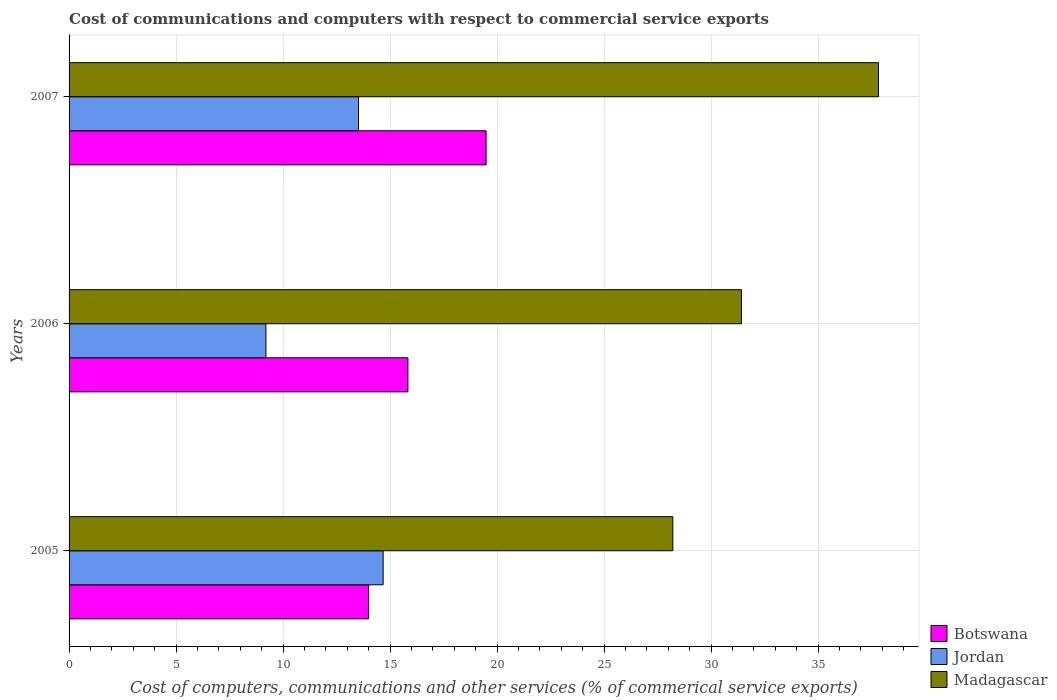How many groups of bars are there?
Give a very brief answer. 3. Are the number of bars on each tick of the Y-axis equal?
Offer a very short reply. Yes. In how many cases, is the number of bars for a given year not equal to the number of legend labels?
Ensure brevity in your answer.  0. What is the cost of communications and computers in Botswana in 2005?
Give a very brief answer. 14. Across all years, what is the maximum cost of communications and computers in Botswana?
Your response must be concise. 19.49. Across all years, what is the minimum cost of communications and computers in Botswana?
Offer a very short reply. 14. What is the total cost of communications and computers in Madagascar in the graph?
Your answer should be very brief. 97.46. What is the difference between the cost of communications and computers in Botswana in 2005 and that in 2007?
Provide a succinct answer. -5.49. What is the difference between the cost of communications and computers in Madagascar in 2005 and the cost of communications and computers in Botswana in 2007?
Make the answer very short. 8.73. What is the average cost of communications and computers in Botswana per year?
Offer a terse response. 16.44. In the year 2006, what is the difference between the cost of communications and computers in Madagascar and cost of communications and computers in Botswana?
Your answer should be compact. 15.59. What is the ratio of the cost of communications and computers in Botswana in 2005 to that in 2006?
Offer a very short reply. 0.88. Is the cost of communications and computers in Jordan in 2006 less than that in 2007?
Make the answer very short. Yes. Is the difference between the cost of communications and computers in Madagascar in 2006 and 2007 greater than the difference between the cost of communications and computers in Botswana in 2006 and 2007?
Provide a short and direct response. No. What is the difference between the highest and the second highest cost of communications and computers in Madagascar?
Your answer should be compact. 6.41. What is the difference between the highest and the lowest cost of communications and computers in Botswana?
Provide a succinct answer. 5.49. In how many years, is the cost of communications and computers in Madagascar greater than the average cost of communications and computers in Madagascar taken over all years?
Offer a very short reply. 1. Is the sum of the cost of communications and computers in Jordan in 2005 and 2006 greater than the maximum cost of communications and computers in Madagascar across all years?
Your answer should be very brief. No. What does the 3rd bar from the top in 2006 represents?
Your response must be concise. Botswana. What does the 3rd bar from the bottom in 2006 represents?
Ensure brevity in your answer.  Madagascar. How many bars are there?
Give a very brief answer. 9. Does the graph contain any zero values?
Your answer should be compact. No. Does the graph contain grids?
Your response must be concise. Yes. What is the title of the graph?
Your answer should be compact. Cost of communications and computers with respect to commercial service exports. What is the label or title of the X-axis?
Your answer should be very brief. Cost of computers, communications and other services (% of commerical service exports). What is the Cost of computers, communications and other services (% of commerical service exports) in Botswana in 2005?
Your response must be concise. 14. What is the Cost of computers, communications and other services (% of commerical service exports) of Jordan in 2005?
Make the answer very short. 14.68. What is the Cost of computers, communications and other services (% of commerical service exports) of Madagascar in 2005?
Keep it short and to the point. 28.21. What is the Cost of computers, communications and other services (% of commerical service exports) of Botswana in 2006?
Give a very brief answer. 15.83. What is the Cost of computers, communications and other services (% of commerical service exports) in Jordan in 2006?
Your answer should be compact. 9.2. What is the Cost of computers, communications and other services (% of commerical service exports) in Madagascar in 2006?
Provide a short and direct response. 31.42. What is the Cost of computers, communications and other services (% of commerical service exports) of Botswana in 2007?
Provide a succinct answer. 19.49. What is the Cost of computers, communications and other services (% of commerical service exports) of Jordan in 2007?
Offer a terse response. 13.53. What is the Cost of computers, communications and other services (% of commerical service exports) of Madagascar in 2007?
Provide a short and direct response. 37.83. Across all years, what is the maximum Cost of computers, communications and other services (% of commerical service exports) of Botswana?
Keep it short and to the point. 19.49. Across all years, what is the maximum Cost of computers, communications and other services (% of commerical service exports) in Jordan?
Offer a very short reply. 14.68. Across all years, what is the maximum Cost of computers, communications and other services (% of commerical service exports) of Madagascar?
Your answer should be compact. 37.83. Across all years, what is the minimum Cost of computers, communications and other services (% of commerical service exports) of Botswana?
Provide a succinct answer. 14. Across all years, what is the minimum Cost of computers, communications and other services (% of commerical service exports) in Jordan?
Your answer should be compact. 9.2. Across all years, what is the minimum Cost of computers, communications and other services (% of commerical service exports) of Madagascar?
Give a very brief answer. 28.21. What is the total Cost of computers, communications and other services (% of commerical service exports) in Botswana in the graph?
Offer a terse response. 49.32. What is the total Cost of computers, communications and other services (% of commerical service exports) of Jordan in the graph?
Your answer should be compact. 37.4. What is the total Cost of computers, communications and other services (% of commerical service exports) of Madagascar in the graph?
Provide a succinct answer. 97.46. What is the difference between the Cost of computers, communications and other services (% of commerical service exports) of Botswana in 2005 and that in 2006?
Offer a very short reply. -1.83. What is the difference between the Cost of computers, communications and other services (% of commerical service exports) of Jordan in 2005 and that in 2006?
Your response must be concise. 5.48. What is the difference between the Cost of computers, communications and other services (% of commerical service exports) of Madagascar in 2005 and that in 2006?
Your answer should be compact. -3.21. What is the difference between the Cost of computers, communications and other services (% of commerical service exports) of Botswana in 2005 and that in 2007?
Provide a short and direct response. -5.49. What is the difference between the Cost of computers, communications and other services (% of commerical service exports) in Jordan in 2005 and that in 2007?
Keep it short and to the point. 1.15. What is the difference between the Cost of computers, communications and other services (% of commerical service exports) in Madagascar in 2005 and that in 2007?
Give a very brief answer. -9.61. What is the difference between the Cost of computers, communications and other services (% of commerical service exports) of Botswana in 2006 and that in 2007?
Provide a succinct answer. -3.65. What is the difference between the Cost of computers, communications and other services (% of commerical service exports) in Jordan in 2006 and that in 2007?
Ensure brevity in your answer.  -4.33. What is the difference between the Cost of computers, communications and other services (% of commerical service exports) of Madagascar in 2006 and that in 2007?
Ensure brevity in your answer.  -6.41. What is the difference between the Cost of computers, communications and other services (% of commerical service exports) in Botswana in 2005 and the Cost of computers, communications and other services (% of commerical service exports) in Jordan in 2006?
Provide a short and direct response. 4.8. What is the difference between the Cost of computers, communications and other services (% of commerical service exports) in Botswana in 2005 and the Cost of computers, communications and other services (% of commerical service exports) in Madagascar in 2006?
Your answer should be very brief. -17.42. What is the difference between the Cost of computers, communications and other services (% of commerical service exports) in Jordan in 2005 and the Cost of computers, communications and other services (% of commerical service exports) in Madagascar in 2006?
Provide a succinct answer. -16.74. What is the difference between the Cost of computers, communications and other services (% of commerical service exports) in Botswana in 2005 and the Cost of computers, communications and other services (% of commerical service exports) in Jordan in 2007?
Your answer should be very brief. 0.48. What is the difference between the Cost of computers, communications and other services (% of commerical service exports) in Botswana in 2005 and the Cost of computers, communications and other services (% of commerical service exports) in Madagascar in 2007?
Your response must be concise. -23.82. What is the difference between the Cost of computers, communications and other services (% of commerical service exports) of Jordan in 2005 and the Cost of computers, communications and other services (% of commerical service exports) of Madagascar in 2007?
Your answer should be compact. -23.15. What is the difference between the Cost of computers, communications and other services (% of commerical service exports) in Botswana in 2006 and the Cost of computers, communications and other services (% of commerical service exports) in Jordan in 2007?
Give a very brief answer. 2.31. What is the difference between the Cost of computers, communications and other services (% of commerical service exports) in Botswana in 2006 and the Cost of computers, communications and other services (% of commerical service exports) in Madagascar in 2007?
Give a very brief answer. -21.99. What is the difference between the Cost of computers, communications and other services (% of commerical service exports) in Jordan in 2006 and the Cost of computers, communications and other services (% of commerical service exports) in Madagascar in 2007?
Your response must be concise. -28.63. What is the average Cost of computers, communications and other services (% of commerical service exports) in Botswana per year?
Offer a terse response. 16.44. What is the average Cost of computers, communications and other services (% of commerical service exports) in Jordan per year?
Your response must be concise. 12.47. What is the average Cost of computers, communications and other services (% of commerical service exports) in Madagascar per year?
Keep it short and to the point. 32.49. In the year 2005, what is the difference between the Cost of computers, communications and other services (% of commerical service exports) in Botswana and Cost of computers, communications and other services (% of commerical service exports) in Jordan?
Give a very brief answer. -0.68. In the year 2005, what is the difference between the Cost of computers, communications and other services (% of commerical service exports) of Botswana and Cost of computers, communications and other services (% of commerical service exports) of Madagascar?
Offer a terse response. -14.21. In the year 2005, what is the difference between the Cost of computers, communications and other services (% of commerical service exports) of Jordan and Cost of computers, communications and other services (% of commerical service exports) of Madagascar?
Your response must be concise. -13.54. In the year 2006, what is the difference between the Cost of computers, communications and other services (% of commerical service exports) in Botswana and Cost of computers, communications and other services (% of commerical service exports) in Jordan?
Provide a short and direct response. 6.63. In the year 2006, what is the difference between the Cost of computers, communications and other services (% of commerical service exports) in Botswana and Cost of computers, communications and other services (% of commerical service exports) in Madagascar?
Keep it short and to the point. -15.59. In the year 2006, what is the difference between the Cost of computers, communications and other services (% of commerical service exports) in Jordan and Cost of computers, communications and other services (% of commerical service exports) in Madagascar?
Make the answer very short. -22.22. In the year 2007, what is the difference between the Cost of computers, communications and other services (% of commerical service exports) of Botswana and Cost of computers, communications and other services (% of commerical service exports) of Jordan?
Give a very brief answer. 5.96. In the year 2007, what is the difference between the Cost of computers, communications and other services (% of commerical service exports) of Botswana and Cost of computers, communications and other services (% of commerical service exports) of Madagascar?
Provide a succinct answer. -18.34. In the year 2007, what is the difference between the Cost of computers, communications and other services (% of commerical service exports) of Jordan and Cost of computers, communications and other services (% of commerical service exports) of Madagascar?
Your answer should be compact. -24.3. What is the ratio of the Cost of computers, communications and other services (% of commerical service exports) of Botswana in 2005 to that in 2006?
Ensure brevity in your answer.  0.88. What is the ratio of the Cost of computers, communications and other services (% of commerical service exports) of Jordan in 2005 to that in 2006?
Ensure brevity in your answer.  1.6. What is the ratio of the Cost of computers, communications and other services (% of commerical service exports) of Madagascar in 2005 to that in 2006?
Give a very brief answer. 0.9. What is the ratio of the Cost of computers, communications and other services (% of commerical service exports) in Botswana in 2005 to that in 2007?
Offer a very short reply. 0.72. What is the ratio of the Cost of computers, communications and other services (% of commerical service exports) in Jordan in 2005 to that in 2007?
Your answer should be very brief. 1.09. What is the ratio of the Cost of computers, communications and other services (% of commerical service exports) of Madagascar in 2005 to that in 2007?
Offer a very short reply. 0.75. What is the ratio of the Cost of computers, communications and other services (% of commerical service exports) in Botswana in 2006 to that in 2007?
Give a very brief answer. 0.81. What is the ratio of the Cost of computers, communications and other services (% of commerical service exports) of Jordan in 2006 to that in 2007?
Ensure brevity in your answer.  0.68. What is the ratio of the Cost of computers, communications and other services (% of commerical service exports) of Madagascar in 2006 to that in 2007?
Your answer should be compact. 0.83. What is the difference between the highest and the second highest Cost of computers, communications and other services (% of commerical service exports) in Botswana?
Your answer should be very brief. 3.65. What is the difference between the highest and the second highest Cost of computers, communications and other services (% of commerical service exports) of Jordan?
Give a very brief answer. 1.15. What is the difference between the highest and the second highest Cost of computers, communications and other services (% of commerical service exports) of Madagascar?
Offer a very short reply. 6.41. What is the difference between the highest and the lowest Cost of computers, communications and other services (% of commerical service exports) in Botswana?
Your answer should be very brief. 5.49. What is the difference between the highest and the lowest Cost of computers, communications and other services (% of commerical service exports) in Jordan?
Ensure brevity in your answer.  5.48. What is the difference between the highest and the lowest Cost of computers, communications and other services (% of commerical service exports) in Madagascar?
Ensure brevity in your answer.  9.61. 